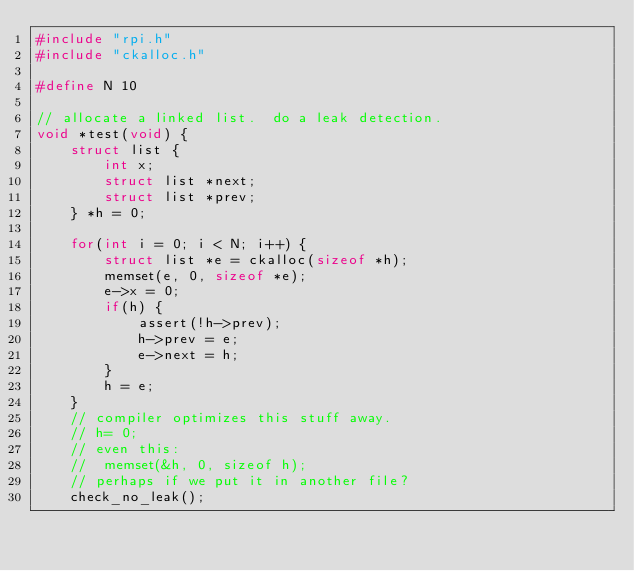<code> <loc_0><loc_0><loc_500><loc_500><_C_>#include "rpi.h"
#include "ckalloc.h"

#define N 10

// allocate a linked list.  do a leak detection.
void *test(void) {
    struct list {
        int x; 
        struct list *next;
        struct list *prev;
    } *h = 0;

    for(int i = 0; i < N; i++) {
        struct list *e = ckalloc(sizeof *h);
        memset(e, 0, sizeof *e);
        e->x = 0;
        if(h) {
            assert(!h->prev);
            h->prev = e;
            e->next = h;
        }
        h = e;
    }
    // compiler optimizes this stuff away.
    // h= 0;
    // even this:
    //  memset(&h, 0, sizeof h);
    // perhaps if we put it in another file?
    check_no_leak();</code> 